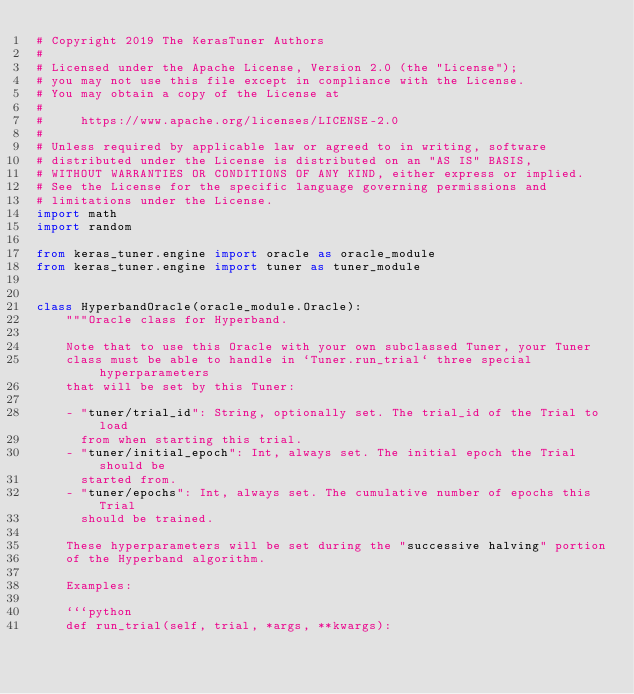Convert code to text. <code><loc_0><loc_0><loc_500><loc_500><_Python_># Copyright 2019 The KerasTuner Authors
#
# Licensed under the Apache License, Version 2.0 (the "License");
# you may not use this file except in compliance with the License.
# You may obtain a copy of the License at
#
#     https://www.apache.org/licenses/LICENSE-2.0
#
# Unless required by applicable law or agreed to in writing, software
# distributed under the License is distributed on an "AS IS" BASIS,
# WITHOUT WARRANTIES OR CONDITIONS OF ANY KIND, either express or implied.
# See the License for the specific language governing permissions and
# limitations under the License.
import math
import random

from keras_tuner.engine import oracle as oracle_module
from keras_tuner.engine import tuner as tuner_module


class HyperbandOracle(oracle_module.Oracle):
    """Oracle class for Hyperband.

    Note that to use this Oracle with your own subclassed Tuner, your Tuner
    class must be able to handle in `Tuner.run_trial` three special hyperparameters
    that will be set by this Tuner:

    - "tuner/trial_id": String, optionally set. The trial_id of the Trial to load
      from when starting this trial.
    - "tuner/initial_epoch": Int, always set. The initial epoch the Trial should be
      started from.
    - "tuner/epochs": Int, always set. The cumulative number of epochs this Trial
      should be trained.

    These hyperparameters will be set during the "successive halving" portion
    of the Hyperband algorithm.

    Examples:

    ```python
    def run_trial(self, trial, *args, **kwargs):</code> 